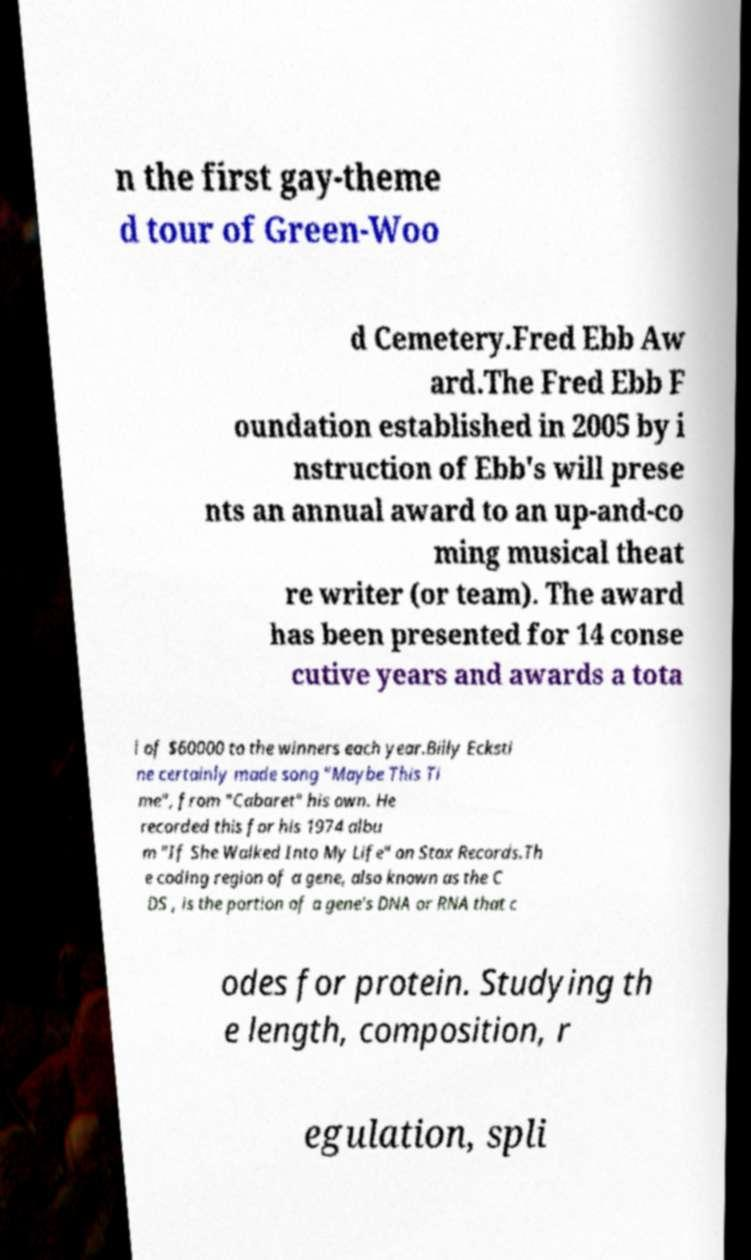Please identify and transcribe the text found in this image. n the first gay-theme d tour of Green-Woo d Cemetery.Fred Ebb Aw ard.The Fred Ebb F oundation established in 2005 by i nstruction of Ebb's will prese nts an annual award to an up-and-co ming musical theat re writer (or team). The award has been presented for 14 conse cutive years and awards a tota l of $60000 to the winners each year.Billy Ecksti ne certainly made song "Maybe This Ti me", from "Cabaret" his own. He recorded this for his 1974 albu m "If She Walked Into My Life" on Stax Records.Th e coding region of a gene, also known as the C DS , is the portion of a gene's DNA or RNA that c odes for protein. Studying th e length, composition, r egulation, spli 